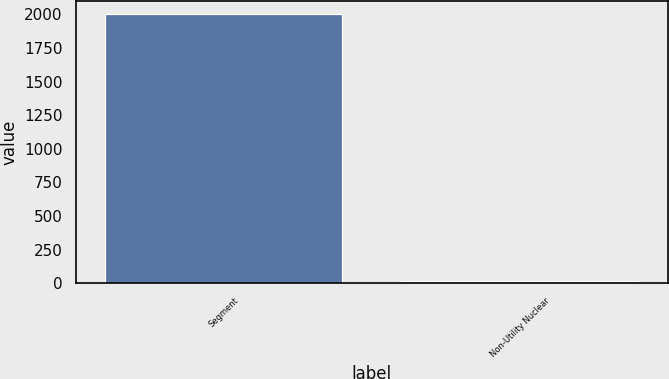<chart> <loc_0><loc_0><loc_500><loc_500><bar_chart><fcel>Segment<fcel>Non-Utility Nuclear<nl><fcel>2002<fcel>16<nl></chart> 